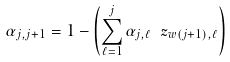<formula> <loc_0><loc_0><loc_500><loc_500>\alpha _ { j , j + 1 } = 1 - \left ( \sum _ { \ell = 1 } ^ { j } \alpha _ { j , \ell } \ z _ { w ( j + 1 ) , \ell } \right )</formula> 